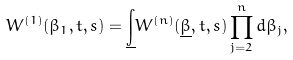Convert formula to latex. <formula><loc_0><loc_0><loc_500><loc_500>W ^ { ( 1 ) } ( \beta _ { 1 } , t , s ) = \underline { \int } W ^ { ( n ) } ( \underline { \beta } , t , s ) \prod _ { j = 2 } ^ { n } d \beta _ { j } ,</formula> 